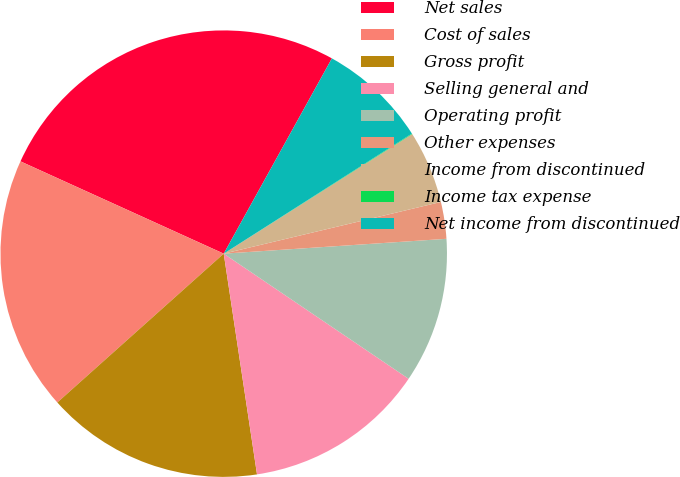Convert chart to OTSL. <chart><loc_0><loc_0><loc_500><loc_500><pie_chart><fcel>Net sales<fcel>Cost of sales<fcel>Gross profit<fcel>Selling general and<fcel>Operating profit<fcel>Other expenses<fcel>Income from discontinued<fcel>Income tax expense<fcel>Net income from discontinued<nl><fcel>26.27%<fcel>18.4%<fcel>15.77%<fcel>13.15%<fcel>10.53%<fcel>2.66%<fcel>5.28%<fcel>0.04%<fcel>7.91%<nl></chart> 